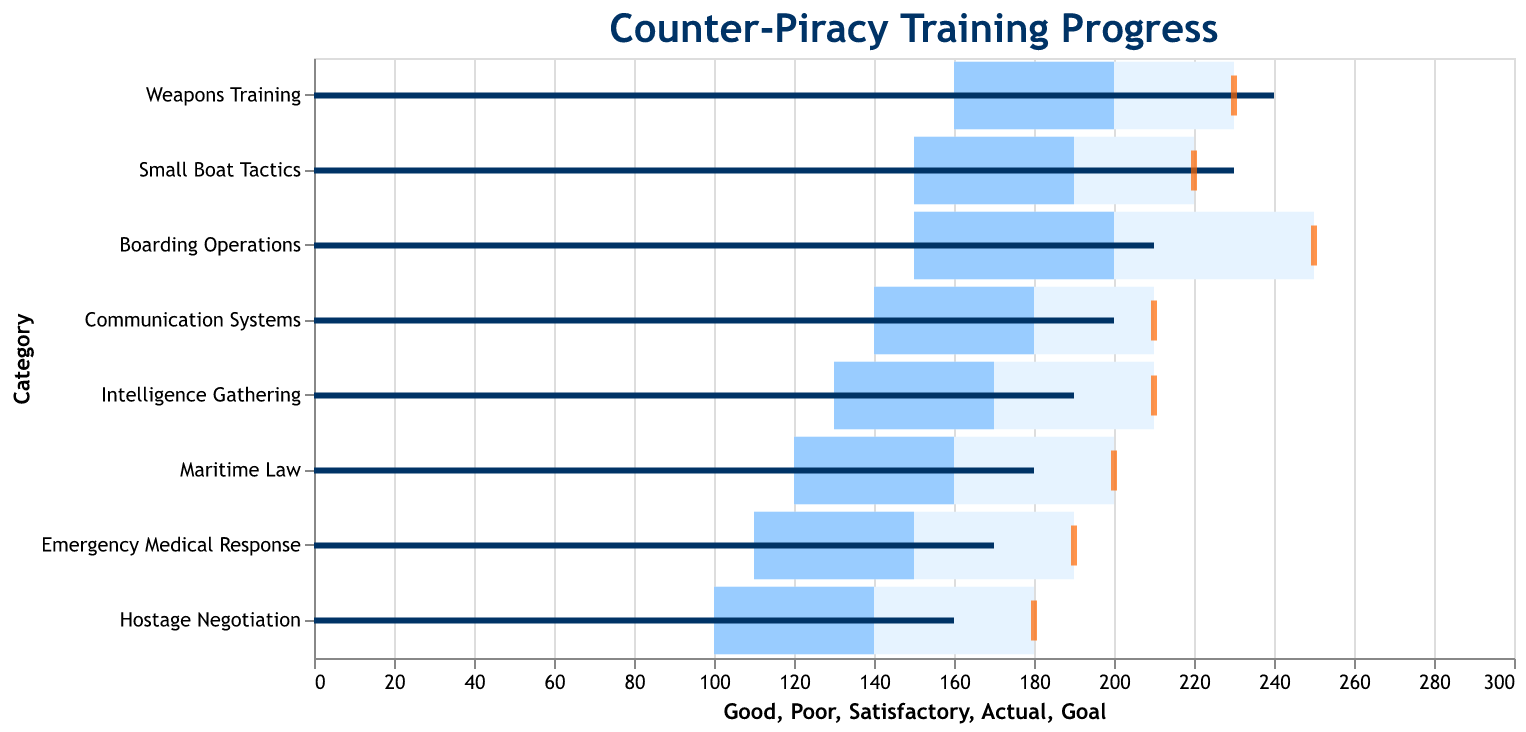What is the title of the figure? The title is typically found at the top of the figure and provides an overview of what the chart represents. In this case, the title is "Counter-Piracy Training Progress."
Answer: Counter-Piracy Training Progress What category has the highest number of actual training hours completed? Look at the bar representing actual training hours (dark blue) for each category and find the one with the longest bar.
Answer: Weapons Training What is the goal for Small Boat Tactics training hours? The goal is represented by the orange tick mark; locate the category "Small Boat Tactics" and find the value of this tick.
Answer: 220 How many categories met or exceeded their training goals? Compare the actual training hours (dark blue bar) against the goal (orange tick) for each category to see if the bar reaches or surpasses the tick.
Answer: 3 Which category is furthest below its training goal? Find the category where the difference between the actual training hours (dark blue bar) and the goal (orange tick) is the greatest.
Answer: Maritime Law What's the difference between the actual and goal training hours in Intelligence Gathering? Subtract the actual training hours (190) from the goal (210) for Intelligence Gathering.
Answer: 20 Which category has the biggest gap between satisfactory and good levels? Look at the satisfactory (light blue) and good (lightest blue) ranges for each category and calculate the difference; find the category with the largest difference.
Answer: Emerging Medical Response Did any category exceed their 'Good' training levels? Check if the actual training hours (dark blue bar) extend beyond the 'Good' marker for any category.
Answer: No How many training hours are considered 'Poor' for Hostage Negotiation? Locate the 'Poor' range for the category "Hostage Negotiation" and find the value.
Answer: 100 In which categories did the actual training hours fall into the 'Satisfactory' range? Compare the actual training hours (dark blue bar) to the satisfactory range (light blue); identify categories where the bar fits within this range.
Answer: Boarding Operations, Maritime Law, Intelligence Gathering, Communication Systems 